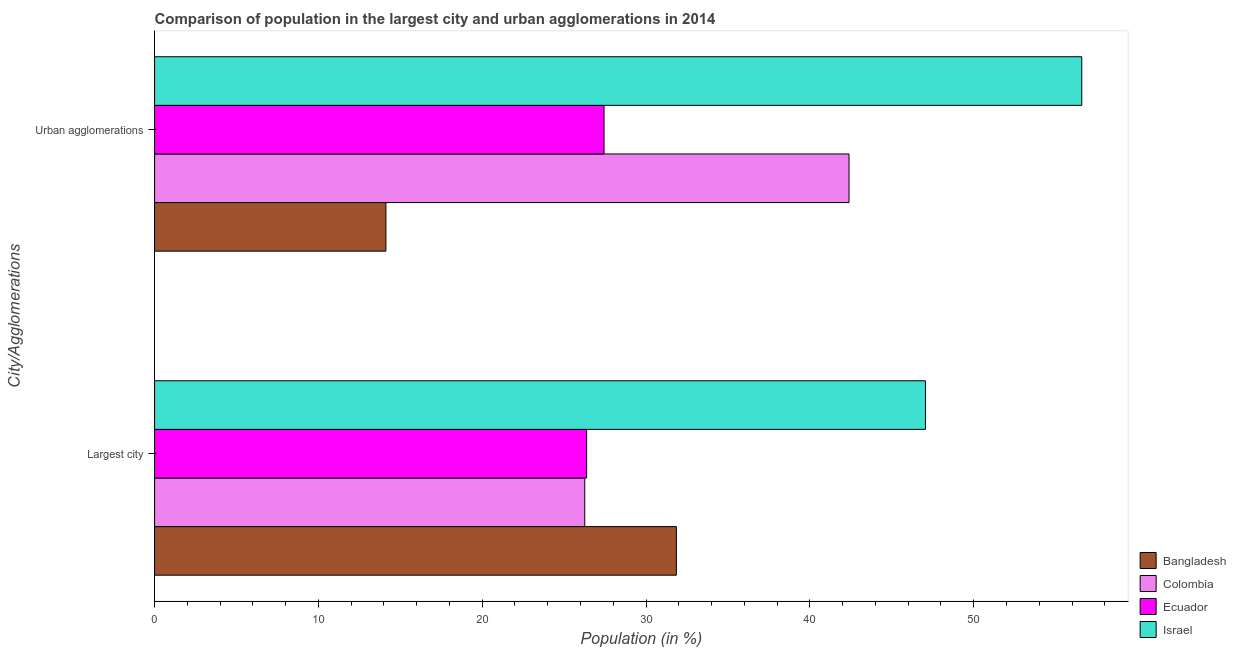How many different coloured bars are there?
Keep it short and to the point. 4. How many groups of bars are there?
Provide a short and direct response. 2. How many bars are there on the 1st tick from the bottom?
Your response must be concise. 4. What is the label of the 1st group of bars from the top?
Give a very brief answer. Urban agglomerations. What is the population in the largest city in Israel?
Keep it short and to the point. 47.06. Across all countries, what is the maximum population in the largest city?
Provide a succinct answer. 47.06. Across all countries, what is the minimum population in the largest city?
Keep it short and to the point. 26.26. What is the total population in the largest city in the graph?
Ensure brevity in your answer.  131.54. What is the difference between the population in urban agglomerations in Ecuador and that in Israel?
Your answer should be very brief. -29.16. What is the difference between the population in the largest city in Ecuador and the population in urban agglomerations in Bangladesh?
Provide a succinct answer. 12.25. What is the average population in urban agglomerations per country?
Your response must be concise. 35.14. What is the difference between the population in the largest city and population in urban agglomerations in Colombia?
Your answer should be very brief. -16.13. In how many countries, is the population in the largest city greater than 10 %?
Offer a very short reply. 4. What is the ratio of the population in the largest city in Colombia to that in Israel?
Your answer should be compact. 0.56. What does the 2nd bar from the top in Urban agglomerations represents?
Ensure brevity in your answer.  Ecuador. What does the 3rd bar from the bottom in Largest city represents?
Provide a succinct answer. Ecuador. How many bars are there?
Offer a terse response. 8. Are all the bars in the graph horizontal?
Give a very brief answer. Yes. What is the difference between two consecutive major ticks on the X-axis?
Provide a succinct answer. 10. Does the graph contain grids?
Your answer should be compact. No. How many legend labels are there?
Offer a very short reply. 4. How are the legend labels stacked?
Offer a terse response. Vertical. What is the title of the graph?
Provide a short and direct response. Comparison of population in the largest city and urban agglomerations in 2014. What is the label or title of the X-axis?
Give a very brief answer. Population (in %). What is the label or title of the Y-axis?
Provide a succinct answer. City/Agglomerations. What is the Population (in %) in Bangladesh in Largest city?
Your answer should be compact. 31.85. What is the Population (in %) in Colombia in Largest city?
Provide a succinct answer. 26.26. What is the Population (in %) in Ecuador in Largest city?
Give a very brief answer. 26.37. What is the Population (in %) of Israel in Largest city?
Your response must be concise. 47.06. What is the Population (in %) of Bangladesh in Urban agglomerations?
Make the answer very short. 14.12. What is the Population (in %) of Colombia in Urban agglomerations?
Provide a short and direct response. 42.39. What is the Population (in %) in Ecuador in Urban agglomerations?
Offer a terse response. 27.44. What is the Population (in %) of Israel in Urban agglomerations?
Give a very brief answer. 56.6. Across all City/Agglomerations, what is the maximum Population (in %) of Bangladesh?
Provide a short and direct response. 31.85. Across all City/Agglomerations, what is the maximum Population (in %) in Colombia?
Provide a succinct answer. 42.39. Across all City/Agglomerations, what is the maximum Population (in %) in Ecuador?
Your answer should be compact. 27.44. Across all City/Agglomerations, what is the maximum Population (in %) in Israel?
Offer a very short reply. 56.6. Across all City/Agglomerations, what is the minimum Population (in %) in Bangladesh?
Offer a very short reply. 14.12. Across all City/Agglomerations, what is the minimum Population (in %) of Colombia?
Provide a short and direct response. 26.26. Across all City/Agglomerations, what is the minimum Population (in %) in Ecuador?
Your response must be concise. 26.37. Across all City/Agglomerations, what is the minimum Population (in %) in Israel?
Give a very brief answer. 47.06. What is the total Population (in %) in Bangladesh in the graph?
Your answer should be very brief. 45.97. What is the total Population (in %) in Colombia in the graph?
Keep it short and to the point. 68.65. What is the total Population (in %) of Ecuador in the graph?
Your answer should be very brief. 53.81. What is the total Population (in %) in Israel in the graph?
Give a very brief answer. 103.65. What is the difference between the Population (in %) of Bangladesh in Largest city and that in Urban agglomerations?
Make the answer very short. 17.73. What is the difference between the Population (in %) in Colombia in Largest city and that in Urban agglomerations?
Offer a very short reply. -16.13. What is the difference between the Population (in %) of Ecuador in Largest city and that in Urban agglomerations?
Your answer should be very brief. -1.06. What is the difference between the Population (in %) in Israel in Largest city and that in Urban agglomerations?
Keep it short and to the point. -9.54. What is the difference between the Population (in %) of Bangladesh in Largest city and the Population (in %) of Colombia in Urban agglomerations?
Make the answer very short. -10.54. What is the difference between the Population (in %) of Bangladesh in Largest city and the Population (in %) of Ecuador in Urban agglomerations?
Your response must be concise. 4.42. What is the difference between the Population (in %) of Bangladesh in Largest city and the Population (in %) of Israel in Urban agglomerations?
Give a very brief answer. -24.74. What is the difference between the Population (in %) in Colombia in Largest city and the Population (in %) in Ecuador in Urban agglomerations?
Your response must be concise. -1.18. What is the difference between the Population (in %) of Colombia in Largest city and the Population (in %) of Israel in Urban agglomerations?
Provide a succinct answer. -30.34. What is the difference between the Population (in %) of Ecuador in Largest city and the Population (in %) of Israel in Urban agglomerations?
Offer a terse response. -30.22. What is the average Population (in %) in Bangladesh per City/Agglomerations?
Make the answer very short. 22.99. What is the average Population (in %) in Colombia per City/Agglomerations?
Provide a succinct answer. 34.32. What is the average Population (in %) of Ecuador per City/Agglomerations?
Keep it short and to the point. 26.9. What is the average Population (in %) of Israel per City/Agglomerations?
Offer a very short reply. 51.83. What is the difference between the Population (in %) in Bangladesh and Population (in %) in Colombia in Largest city?
Make the answer very short. 5.59. What is the difference between the Population (in %) in Bangladesh and Population (in %) in Ecuador in Largest city?
Provide a short and direct response. 5.48. What is the difference between the Population (in %) in Bangladesh and Population (in %) in Israel in Largest city?
Offer a terse response. -15.2. What is the difference between the Population (in %) in Colombia and Population (in %) in Ecuador in Largest city?
Your answer should be very brief. -0.12. What is the difference between the Population (in %) of Colombia and Population (in %) of Israel in Largest city?
Offer a terse response. -20.8. What is the difference between the Population (in %) of Ecuador and Population (in %) of Israel in Largest city?
Keep it short and to the point. -20.68. What is the difference between the Population (in %) of Bangladesh and Population (in %) of Colombia in Urban agglomerations?
Your answer should be very brief. -28.27. What is the difference between the Population (in %) of Bangladesh and Population (in %) of Ecuador in Urban agglomerations?
Provide a short and direct response. -13.31. What is the difference between the Population (in %) in Bangladesh and Population (in %) in Israel in Urban agglomerations?
Your answer should be very brief. -42.48. What is the difference between the Population (in %) of Colombia and Population (in %) of Ecuador in Urban agglomerations?
Your response must be concise. 14.96. What is the difference between the Population (in %) in Colombia and Population (in %) in Israel in Urban agglomerations?
Offer a terse response. -14.21. What is the difference between the Population (in %) of Ecuador and Population (in %) of Israel in Urban agglomerations?
Provide a succinct answer. -29.16. What is the ratio of the Population (in %) of Bangladesh in Largest city to that in Urban agglomerations?
Offer a terse response. 2.26. What is the ratio of the Population (in %) of Colombia in Largest city to that in Urban agglomerations?
Ensure brevity in your answer.  0.62. What is the ratio of the Population (in %) in Ecuador in Largest city to that in Urban agglomerations?
Offer a terse response. 0.96. What is the ratio of the Population (in %) of Israel in Largest city to that in Urban agglomerations?
Make the answer very short. 0.83. What is the difference between the highest and the second highest Population (in %) of Bangladesh?
Offer a terse response. 17.73. What is the difference between the highest and the second highest Population (in %) of Colombia?
Keep it short and to the point. 16.13. What is the difference between the highest and the second highest Population (in %) in Israel?
Your response must be concise. 9.54. What is the difference between the highest and the lowest Population (in %) in Bangladesh?
Your answer should be compact. 17.73. What is the difference between the highest and the lowest Population (in %) in Colombia?
Offer a terse response. 16.13. What is the difference between the highest and the lowest Population (in %) in Ecuador?
Provide a succinct answer. 1.06. What is the difference between the highest and the lowest Population (in %) of Israel?
Your answer should be very brief. 9.54. 